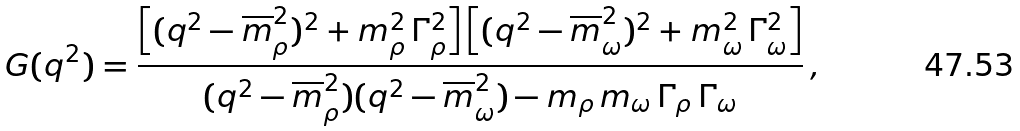<formula> <loc_0><loc_0><loc_500><loc_500>G ( q ^ { 2 } ) = \frac { \left [ ( q ^ { 2 } - \overline { m } _ { \rho } ^ { 2 } ) ^ { 2 } + m _ { \rho } ^ { 2 } \, \Gamma _ { \rho } ^ { 2 } \right ] \left [ ( q ^ { 2 } - \overline { m } _ { \omega } ^ { 2 } ) ^ { 2 } + m _ { \omega } ^ { 2 } \, \Gamma _ { \omega } ^ { 2 } \right ] } { ( q ^ { 2 } - \overline { m } _ { \rho } ^ { 2 } ) ( q ^ { 2 } - \overline { m } _ { \omega } ^ { 2 } ) - m _ { \rho } \, m _ { \omega } \, \Gamma _ { \rho } \, \Gamma _ { \omega } } \, ,</formula> 